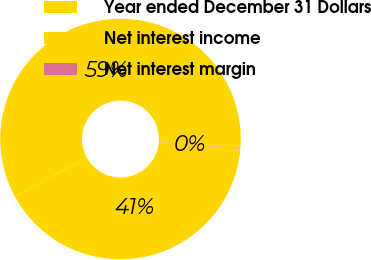Convert chart to OTSL. <chart><loc_0><loc_0><loc_500><loc_500><pie_chart><fcel>Year ended December 31 Dollars<fcel>Net interest income<fcel>Net interest margin<nl><fcel>40.75%<fcel>59.19%<fcel>0.06%<nl></chart> 